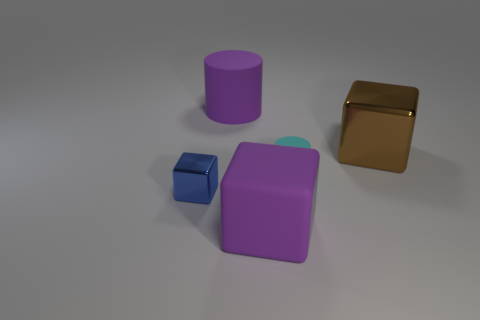What number of rubber things are tiny cylinders or blue blocks?
Provide a short and direct response. 1. There is a metallic thing that is to the left of the big cube behind the large thing in front of the big brown metallic cube; what is its color?
Give a very brief answer. Blue. The other big metal object that is the same shape as the blue shiny object is what color?
Make the answer very short. Brown. Is there any other thing that is the same color as the small cylinder?
Your answer should be compact. No. How many other objects are there of the same material as the cyan cylinder?
Your answer should be compact. 2. The purple cylinder is what size?
Your answer should be compact. Large. Is there another thing that has the same shape as the small cyan rubber object?
Your response must be concise. Yes. What number of objects are tiny metallic objects or metallic blocks to the right of the blue metal block?
Ensure brevity in your answer.  2. The cylinder that is in front of the purple rubber cylinder is what color?
Provide a short and direct response. Cyan. Does the cylinder on the right side of the big purple rubber cylinder have the same size as the metallic object in front of the cyan cylinder?
Your response must be concise. Yes. 